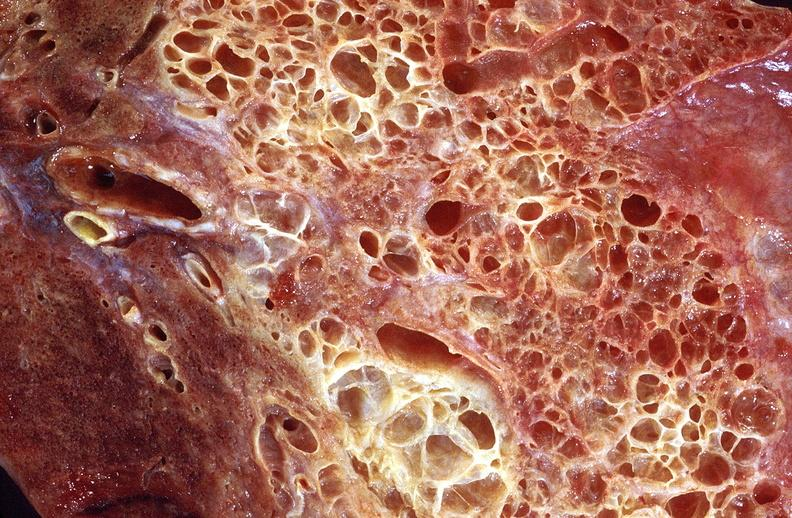what is present?
Answer the question using a single word or phrase. Respiratory 